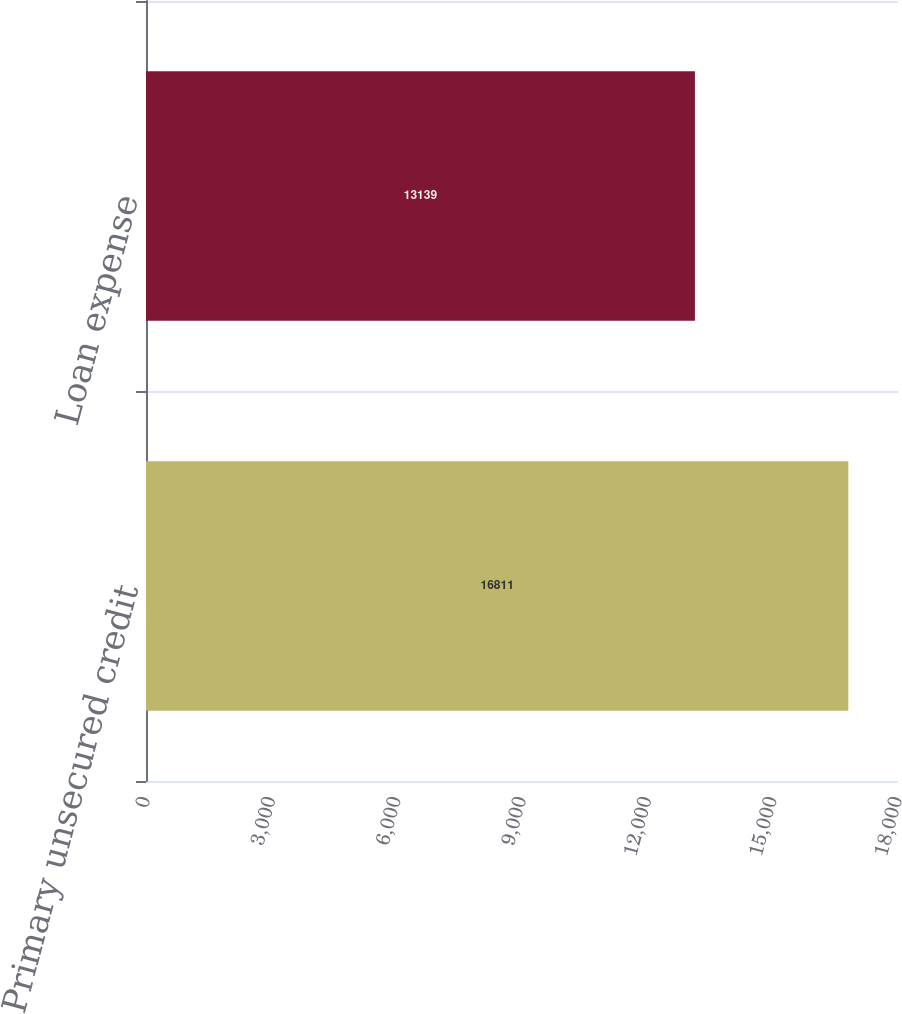Convert chart to OTSL. <chart><loc_0><loc_0><loc_500><loc_500><bar_chart><fcel>Primary unsecured credit<fcel>Loan expense<nl><fcel>16811<fcel>13139<nl></chart> 